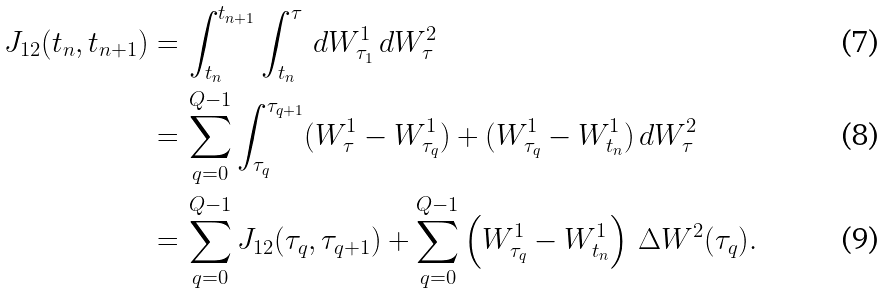<formula> <loc_0><loc_0><loc_500><loc_500>J _ { 1 2 } ( t _ { n } , t _ { n + 1 } ) = & \, \int _ { t _ { n } } ^ { t _ { n + 1 } } \int _ { t _ { n } } ^ { \tau } \, d W _ { \tau _ { 1 } } ^ { 1 } \, d W _ { \tau } ^ { 2 } \\ = & \, \sum _ { q = 0 } ^ { Q - 1 } \int _ { \tau _ { q } } ^ { \tau _ { q + 1 } } ( W _ { \tau } ^ { 1 } - W _ { \tau _ { q } } ^ { 1 } ) + ( W _ { \tau _ { q } } ^ { 1 } - W _ { t _ { n } } ^ { 1 } ) \, d W _ { \tau } ^ { 2 } \\ = & \, \sum _ { q = 0 } ^ { Q - 1 } J _ { 1 2 } ( \tau _ { q } , \tau _ { q + 1 } ) + \sum _ { q = 0 } ^ { Q - 1 } \left ( W _ { \tau _ { q } } ^ { 1 } - W _ { t _ { n } } ^ { 1 } \right ) \, \Delta W ^ { 2 } ( \tau _ { q } ) .</formula> 